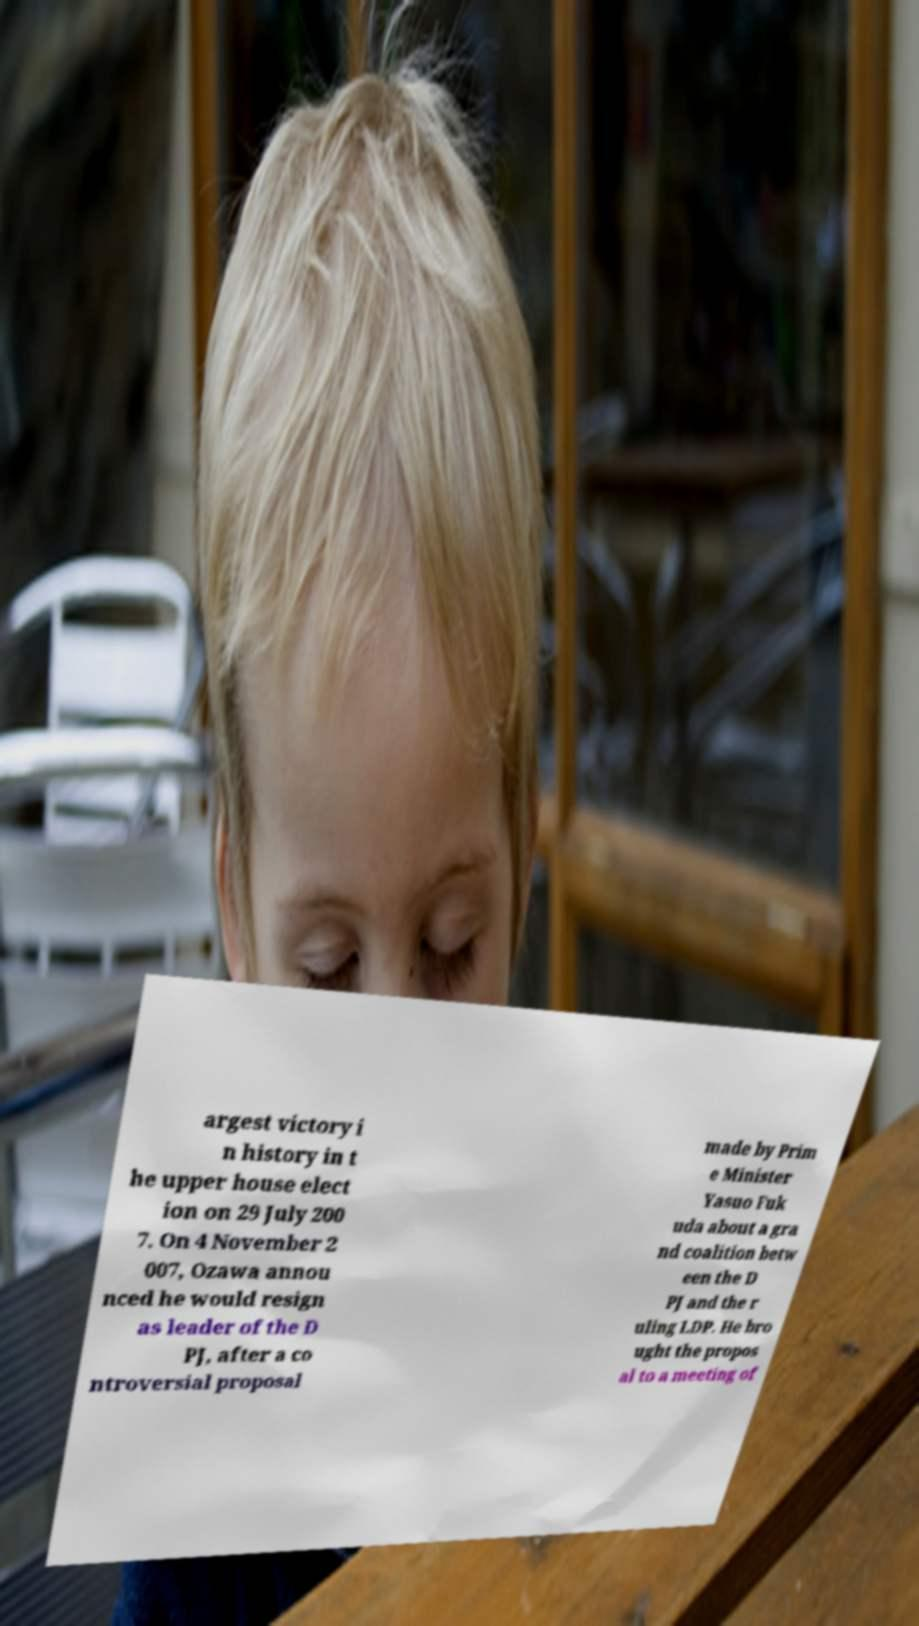Could you assist in decoding the text presented in this image and type it out clearly? argest victory i n history in t he upper house elect ion on 29 July 200 7. On 4 November 2 007, Ozawa annou nced he would resign as leader of the D PJ, after a co ntroversial proposal made by Prim e Minister Yasuo Fuk uda about a gra nd coalition betw een the D PJ and the r uling LDP. He bro ught the propos al to a meeting of 